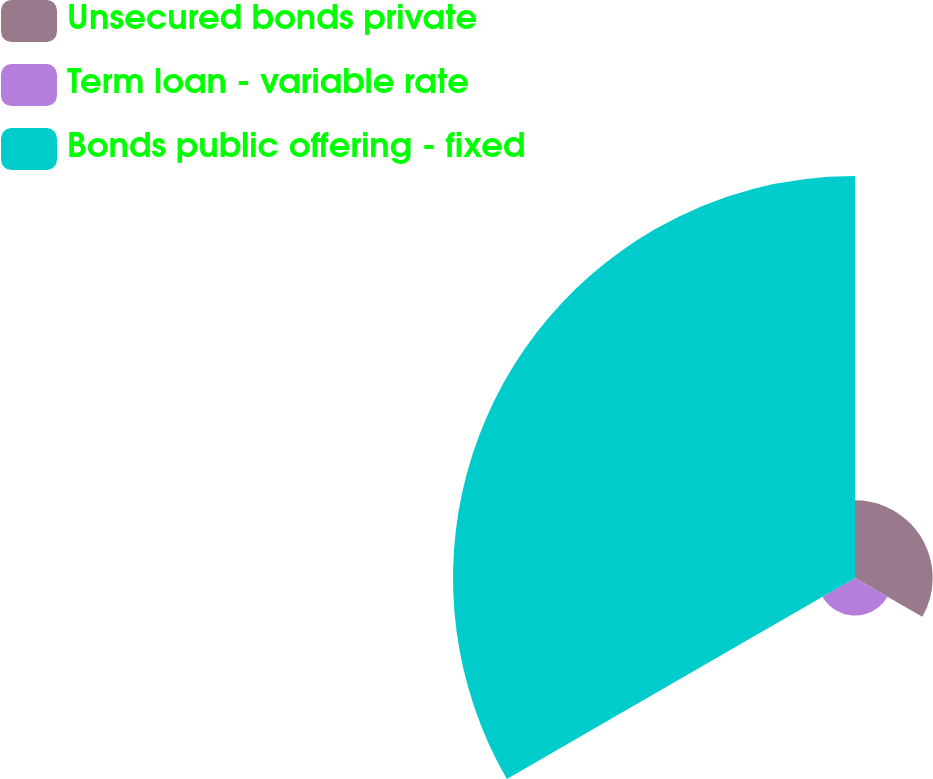Convert chart to OTSL. <chart><loc_0><loc_0><loc_500><loc_500><pie_chart><fcel>Unsecured bonds private<fcel>Term loan - variable rate<fcel>Bonds public offering - fixed<nl><fcel>15.02%<fcel>7.27%<fcel>77.71%<nl></chart> 